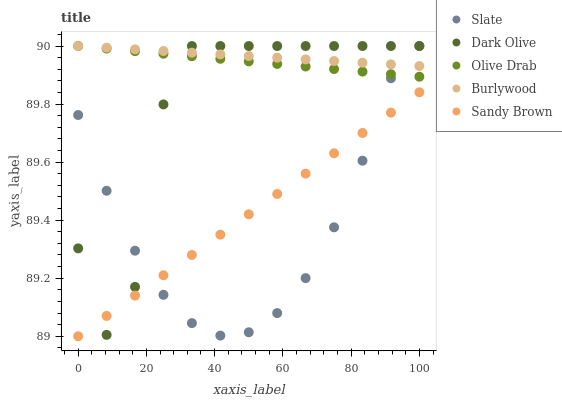Does Slate have the minimum area under the curve?
Answer yes or no. Yes. Does Burlywood have the maximum area under the curve?
Answer yes or no. Yes. Does Dark Olive have the minimum area under the curve?
Answer yes or no. No. Does Dark Olive have the maximum area under the curve?
Answer yes or no. No. Is Sandy Brown the smoothest?
Answer yes or no. Yes. Is Dark Olive the roughest?
Answer yes or no. Yes. Is Slate the smoothest?
Answer yes or no. No. Is Slate the roughest?
Answer yes or no. No. Does Sandy Brown have the lowest value?
Answer yes or no. Yes. Does Slate have the lowest value?
Answer yes or no. No. Does Olive Drab have the highest value?
Answer yes or no. Yes. Does Sandy Brown have the highest value?
Answer yes or no. No. Is Sandy Brown less than Burlywood?
Answer yes or no. Yes. Is Burlywood greater than Sandy Brown?
Answer yes or no. Yes. Does Dark Olive intersect Slate?
Answer yes or no. Yes. Is Dark Olive less than Slate?
Answer yes or no. No. Is Dark Olive greater than Slate?
Answer yes or no. No. Does Sandy Brown intersect Burlywood?
Answer yes or no. No. 